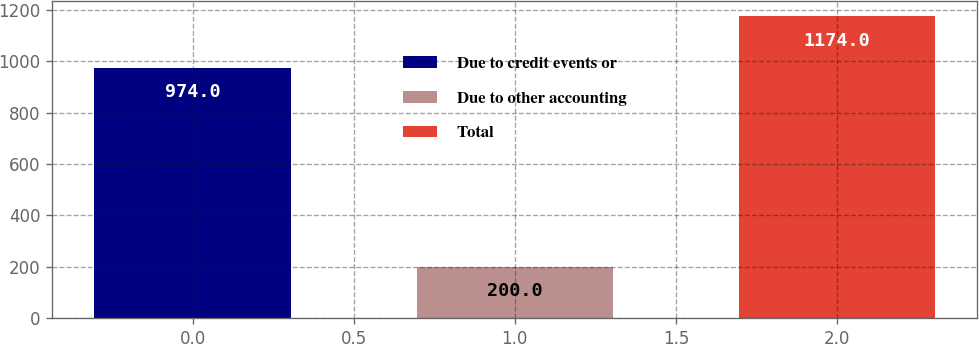<chart> <loc_0><loc_0><loc_500><loc_500><bar_chart><fcel>Due to credit events or<fcel>Due to other accounting<fcel>Total<nl><fcel>974<fcel>200<fcel>1174<nl></chart> 